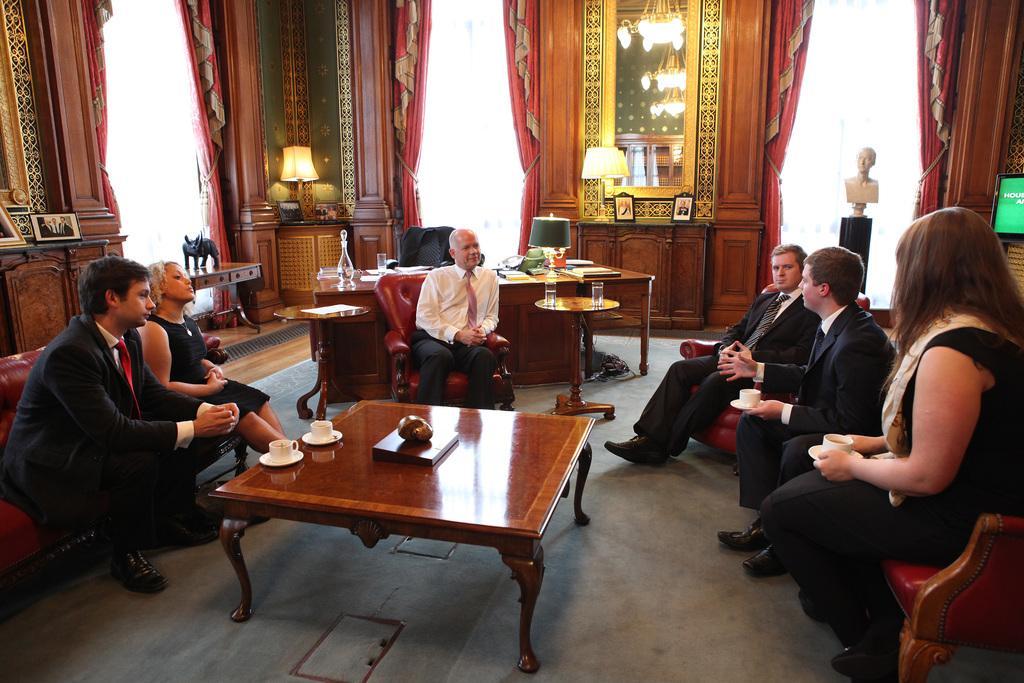Could you give a brief overview of what you see in this image? In a room there are two ladies and fours gents are sitting. In middle of them there is a table. On the table there are two cups. Behind them there is a table. On the table there are some papers, jar. On the chair there is a jacket. To the left side table there are two frames. And we can see curtains, lamps and statues. 